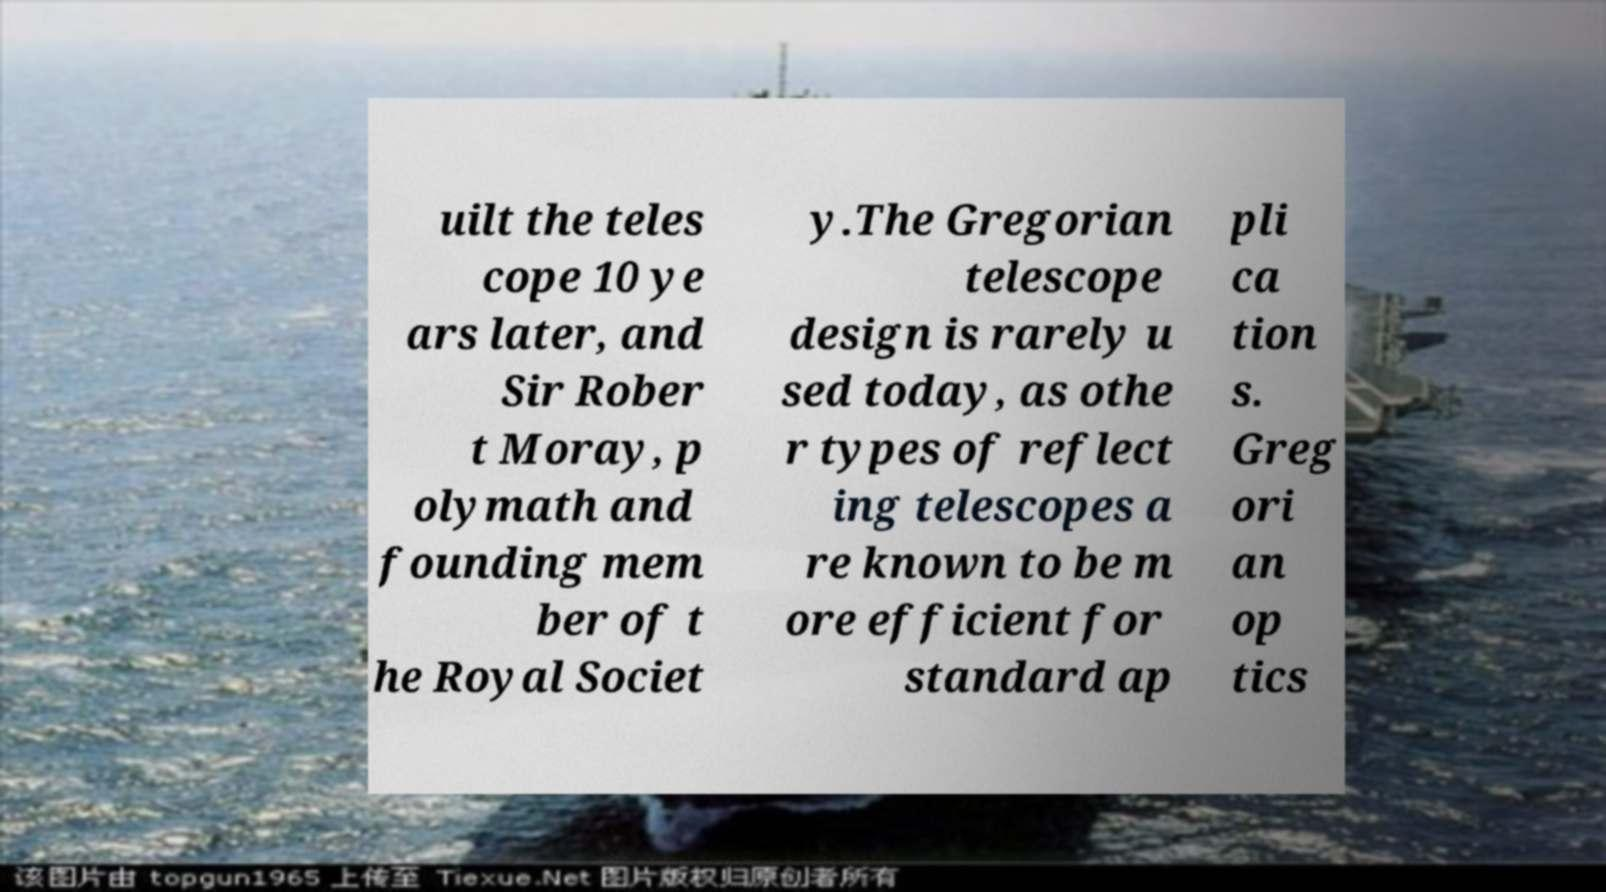Could you extract and type out the text from this image? uilt the teles cope 10 ye ars later, and Sir Rober t Moray, p olymath and founding mem ber of t he Royal Societ y.The Gregorian telescope design is rarely u sed today, as othe r types of reflect ing telescopes a re known to be m ore efficient for standard ap pli ca tion s. Greg ori an op tics 